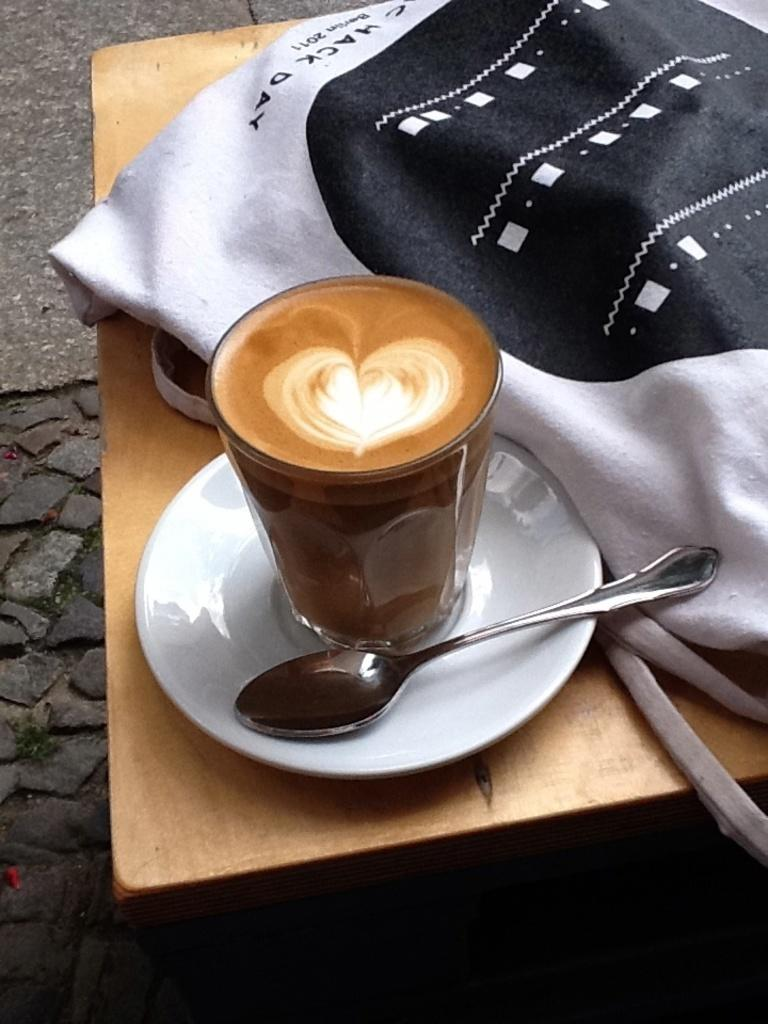What type of table is in the image? There is a wooden table in the image. What is placed on the table? There is a glass with a saucer on the table, along with a spoon. What is the material of the carry bag beside the table items? The carry bag is made of cloth. What can be seen on the carry bag? There is text on the carry bag. What type of oven is visible in the image? There is no oven present in the image. What need is being addressed by the items on the table? The conversation does not provide enough information to determine the specific need being addressed by the items on the table. 